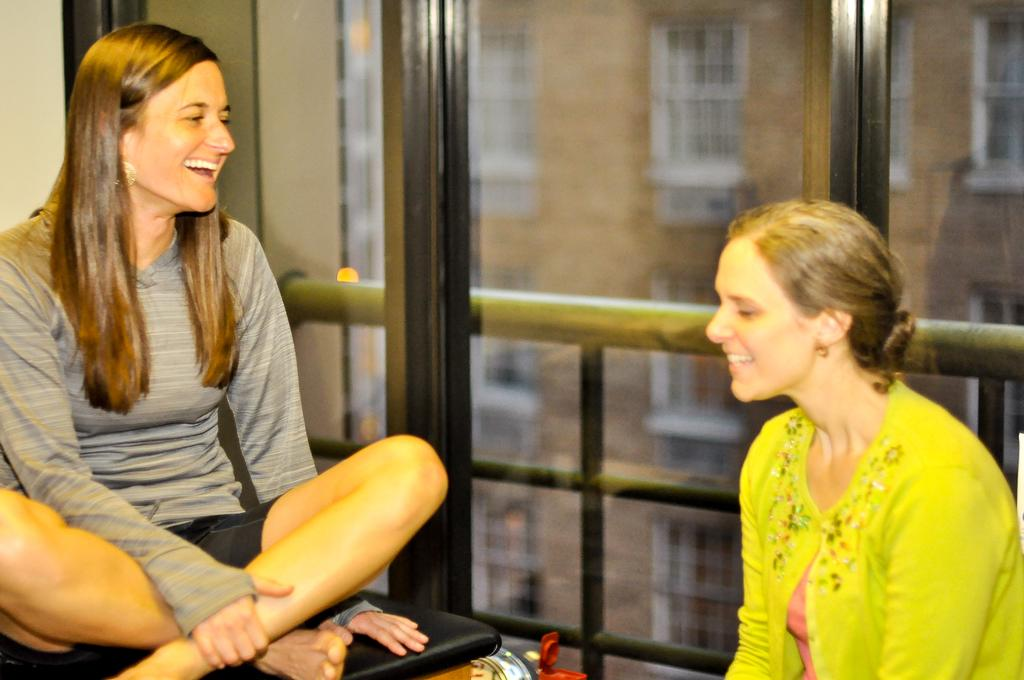How many people are in the image? There are two women in the image. What are the women doing in the image? The women are sitting and smiling. What can be seen in the background of the image? There is a glass window and buildings visible in the background of the image. What type of plantation can be seen through the glass window in the image? There is no plantation visible in the image; only buildings can be seen through the glass window. 